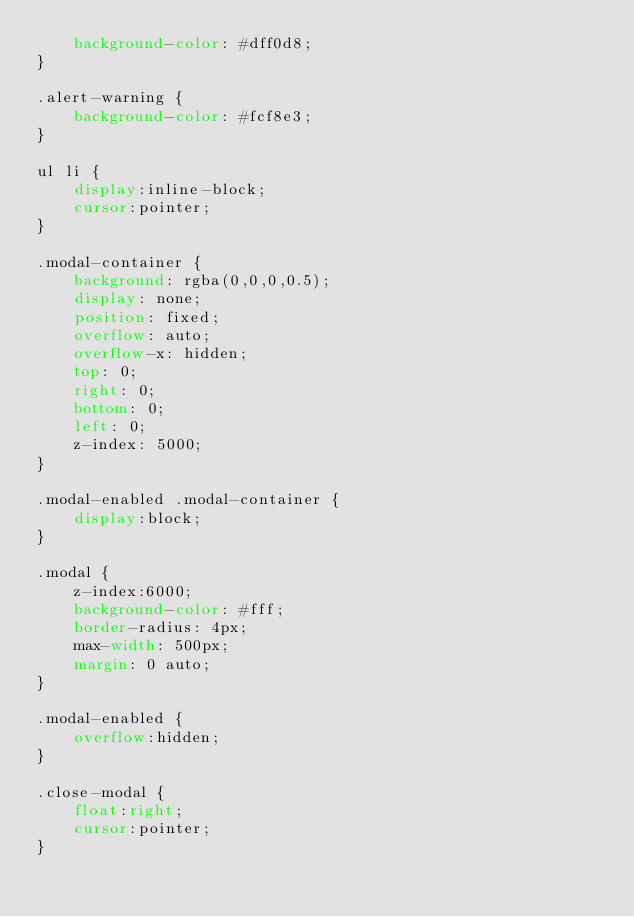Convert code to text. <code><loc_0><loc_0><loc_500><loc_500><_CSS_>    background-color: #dff0d8;
}

.alert-warning {
    background-color: #fcf8e3;
}

ul li {
    display:inline-block;
    cursor:pointer;
}

.modal-container {
    background: rgba(0,0,0,0.5);
    display: none;
    position: fixed;
    overflow: auto;
    overflow-x: hidden;
    top: 0;
    right: 0;
    bottom: 0;
    left: 0;
    z-index: 5000;
}

.modal-enabled .modal-container {
    display:block;
}

.modal {
    z-index:6000;
    background-color: #fff;
    border-radius: 4px;
    max-width: 500px;
    margin: 0 auto;
}

.modal-enabled {
    overflow:hidden;
}

.close-modal {
    float:right;
    cursor:pointer;
}</code> 